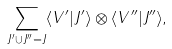<formula> <loc_0><loc_0><loc_500><loc_500>\sum _ { J ^ { \prime } \cup J ^ { \prime \prime } = J } \langle V ^ { \prime } | J ^ { \prime } \rangle \otimes \langle V ^ { \prime \prime } | J ^ { \prime \prime } \rangle ,</formula> 